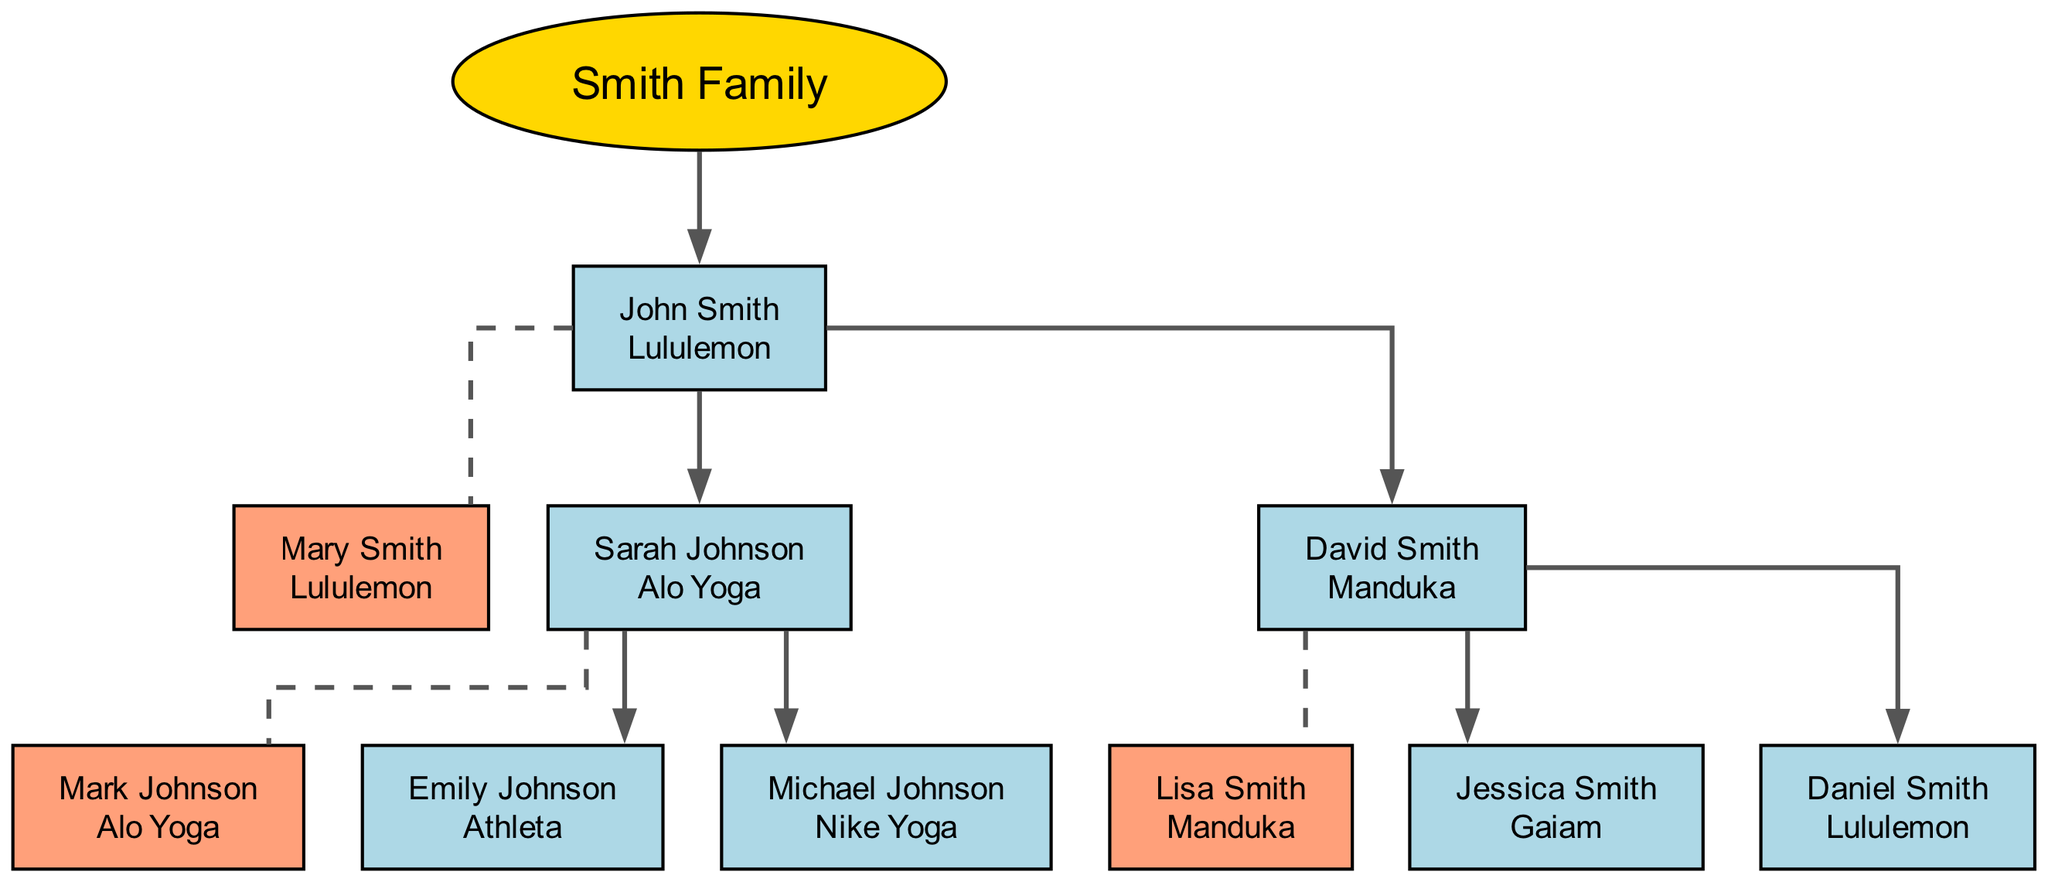What brand is associated with John Smith? John Smith is depicted with a connection to the brand loyalty node indicating "Lululemon." The relationship is shown directly beneath his name on the diagram.
Answer: Lululemon How many children does David Smith have? David Smith's node contains a branch indicating two children, Jessica Smith and Daniel Smith, demonstrating the family structure visually in the diagram.
Answer: 2 What brand loyalty does Jessica Smith exhibit? The diagram shows that Jessica Smith is directly linked to the brand loyalty node that states "Gaiam." This shows her brand loyalty clearly beneath her name.
Answer: Gaiam Which spouse is associated with Sarah Johnson? The diagram indicates a relationship to Mark Johnson, as it shows a dashed line connecting their nodes, signifying a marital connection alongside their individual brands.
Answer: Mark Johnson How many generations are depicted in the diagram? The diagram clearly shows one generation of the Smith family, beginning with John Smith and branching down to his children and grandchildren, showing that there is one group of descendants.
Answer: 1 What is the brand loyalty of Michael Johnson? The diagram provides a direct indication that Michael Johnson is associated with the brand loyalty "Nike Yoga," which is clearly labeled beneath his name.
Answer: Nike Yoga Which brand is associated with David Smith that matches a brand of one of his children? David Smith shows brand loyalty to "Manduka," but his child Daniel Smith shares a brand loyalty with David, presented as "Lululemon," illustrating brand inheritance.
Answer: Lululemon How does the brand loyalty of Emily Johnson differ from her parents? Emily Johnson exhibits brand loyalty to "Athleta," which is distinct from her parents Sarah Johnson (Alo Yoga) and Mark Johnson; indicating that familial brand ties can vary across generations.
Answer: Athleta Which spouse has a direct connection to Lisa Smith in the diagram? Lisa Smith is directly connected as the spouse of David Smith, illustrated by a dashed line between their nodes reflecting their marital status.
Answer: David Smith 